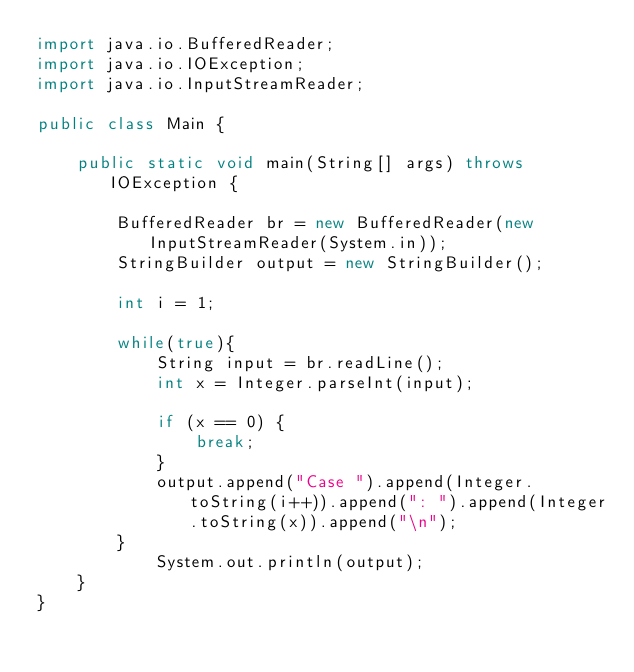Convert code to text. <code><loc_0><loc_0><loc_500><loc_500><_Java_>import java.io.BufferedReader;
import java.io.IOException;
import java.io.InputStreamReader;

public class Main {

    public static void main(String[] args) throws IOException {

        BufferedReader br = new BufferedReader(new InputStreamReader(System.in));
        StringBuilder output = new StringBuilder();

        int i = 1;

        while(true){
            String input = br.readLine();
            int x = Integer.parseInt(input);

            if (x == 0) {
                break;
            }
            output.append("Case ").append(Integer.toString(i++)).append(": ").append(Integer.toString(x)).append("\n");
        }
            System.out.println(output);
    }
}</code> 